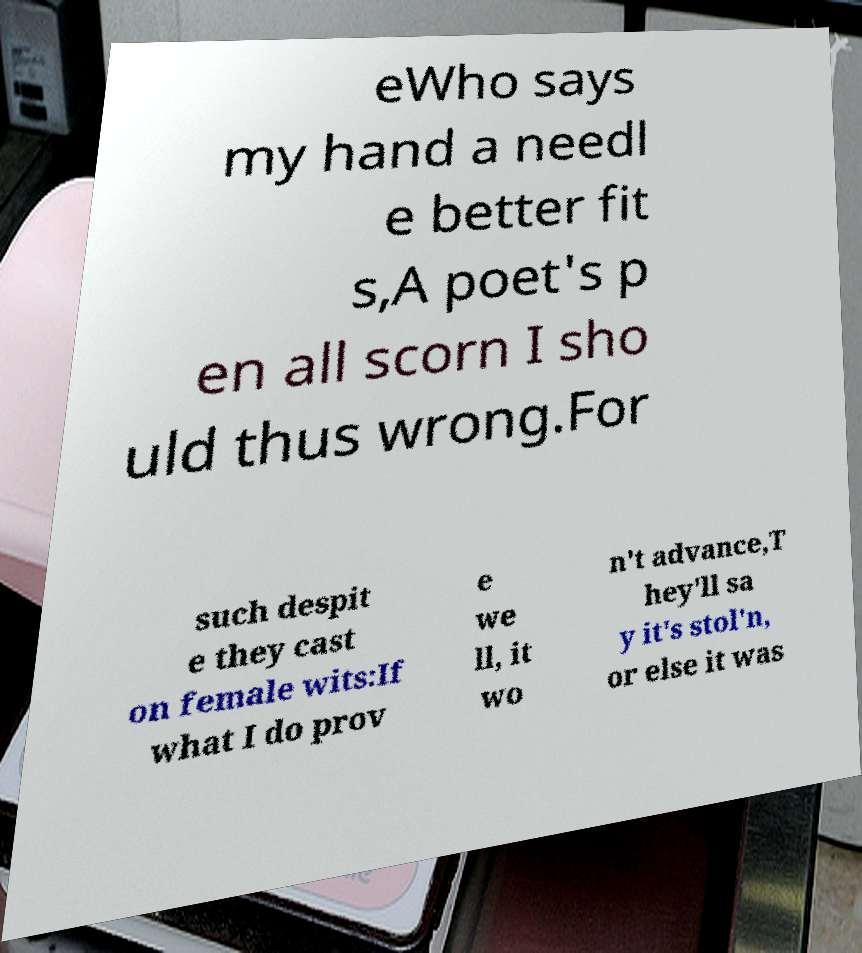For documentation purposes, I need the text within this image transcribed. Could you provide that? eWho says my hand a needl e better fit s,A poet's p en all scorn I sho uld thus wrong.For such despit e they cast on female wits:If what I do prov e we ll, it wo n't advance,T hey'll sa y it's stol'n, or else it was 